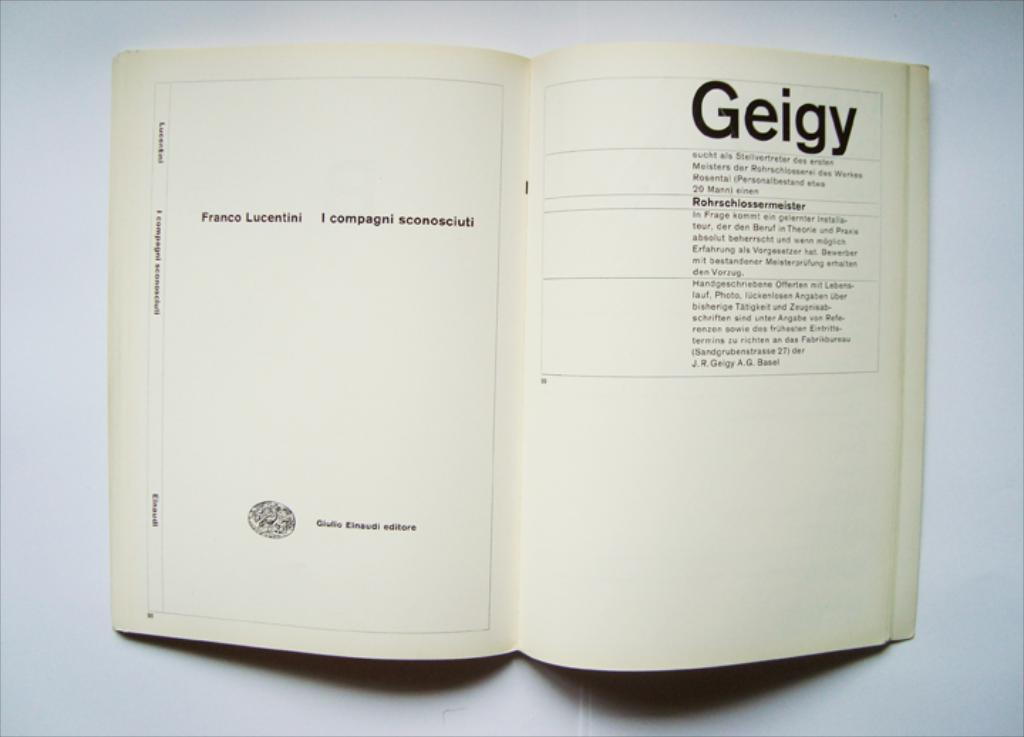<image>
Present a compact description of the photo's key features. Book with the word Geigy and the meaning for the word 